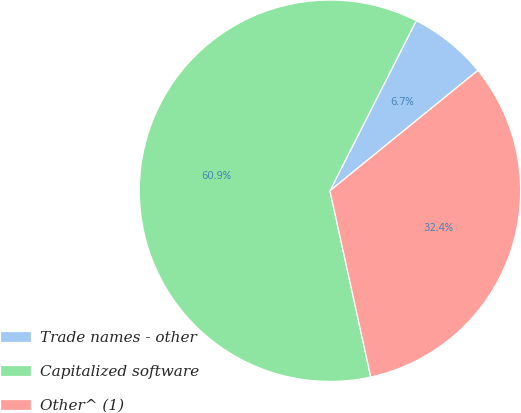<chart> <loc_0><loc_0><loc_500><loc_500><pie_chart><fcel>Trade names - other<fcel>Capitalized software<fcel>Other^ (1)<nl><fcel>6.66%<fcel>60.91%<fcel>32.43%<nl></chart> 